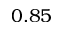Convert formula to latex. <formula><loc_0><loc_0><loc_500><loc_500>0 . 8 5</formula> 